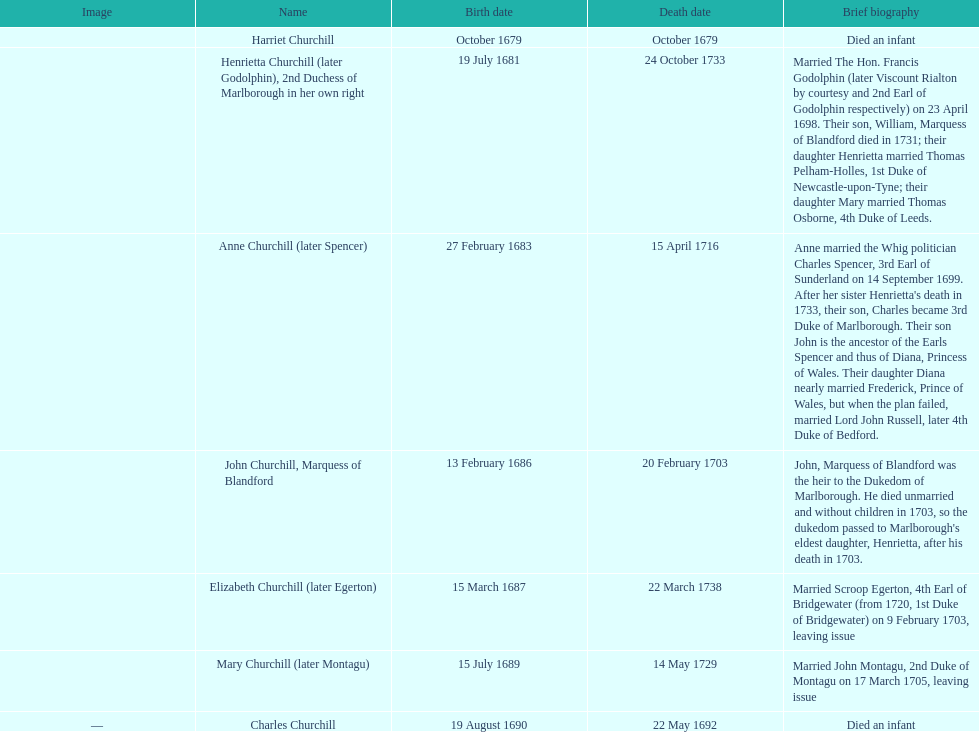Would you be able to parse every entry in this table? {'header': ['Image', 'Name', 'Birth date', 'Death date', 'Brief biography'], 'rows': [['', 'Harriet Churchill', 'October 1679', 'October 1679', 'Died an infant'], ['', 'Henrietta Churchill (later Godolphin), 2nd Duchess of Marlborough in her own right', '19 July 1681', '24 October 1733', 'Married The Hon. Francis Godolphin (later Viscount Rialton by courtesy and 2nd Earl of Godolphin respectively) on 23 April 1698. Their son, William, Marquess of Blandford died in 1731; their daughter Henrietta married Thomas Pelham-Holles, 1st Duke of Newcastle-upon-Tyne; their daughter Mary married Thomas Osborne, 4th Duke of Leeds.'], ['', 'Anne Churchill (later Spencer)', '27 February 1683', '15 April 1716', "Anne married the Whig politician Charles Spencer, 3rd Earl of Sunderland on 14 September 1699. After her sister Henrietta's death in 1733, their son, Charles became 3rd Duke of Marlborough. Their son John is the ancestor of the Earls Spencer and thus of Diana, Princess of Wales. Their daughter Diana nearly married Frederick, Prince of Wales, but when the plan failed, married Lord John Russell, later 4th Duke of Bedford."], ['', 'John Churchill, Marquess of Blandford', '13 February 1686', '20 February 1703', "John, Marquess of Blandford was the heir to the Dukedom of Marlborough. He died unmarried and without children in 1703, so the dukedom passed to Marlborough's eldest daughter, Henrietta, after his death in 1703."], ['', 'Elizabeth Churchill (later Egerton)', '15 March 1687', '22 March 1738', 'Married Scroop Egerton, 4th Earl of Bridgewater (from 1720, 1st Duke of Bridgewater) on 9 February 1703, leaving issue'], ['', 'Mary Churchill (later Montagu)', '15 July 1689', '14 May 1729', 'Married John Montagu, 2nd Duke of Montagu on 17 March 1705, leaving issue'], ['—', 'Charles Churchill', '19 August 1690', '22 May 1692', 'Died an infant']]} What is the total number of children listed? 7. 